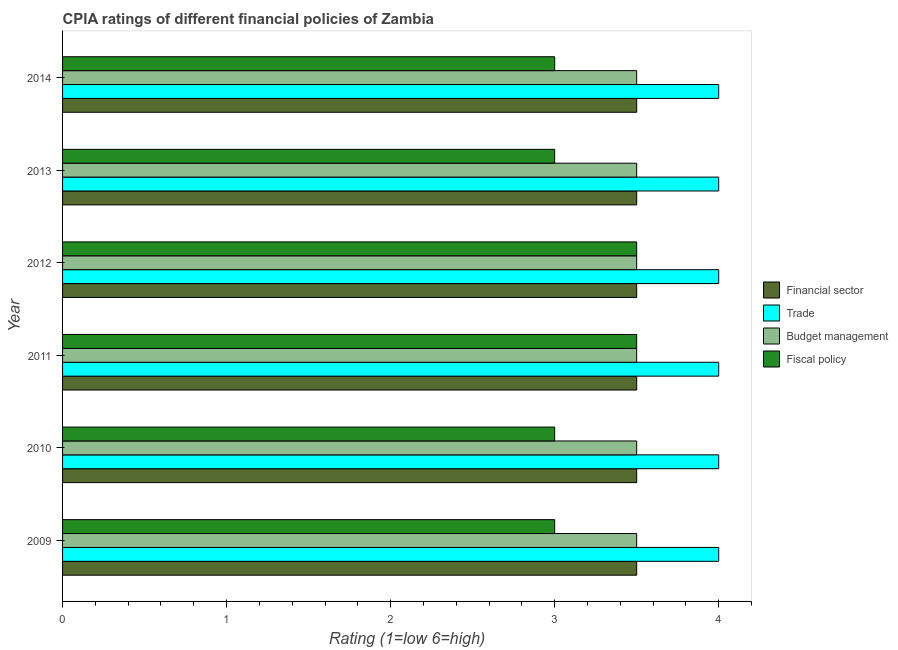How many groups of bars are there?
Offer a very short reply. 6. How many bars are there on the 3rd tick from the top?
Give a very brief answer. 4. How many bars are there on the 6th tick from the bottom?
Give a very brief answer. 4. What is the label of the 1st group of bars from the top?
Your response must be concise. 2014. In how many cases, is the number of bars for a given year not equal to the number of legend labels?
Your response must be concise. 0. Across all years, what is the maximum cpia rating of trade?
Provide a succinct answer. 4. Across all years, what is the minimum cpia rating of trade?
Provide a short and direct response. 4. In which year was the cpia rating of fiscal policy maximum?
Provide a short and direct response. 2011. What is the total cpia rating of financial sector in the graph?
Offer a very short reply. 21. What is the average cpia rating of fiscal policy per year?
Ensure brevity in your answer.  3.17. In the year 2013, what is the difference between the cpia rating of trade and cpia rating of fiscal policy?
Your answer should be very brief. 1. Is the cpia rating of budget management in 2010 less than that in 2013?
Provide a succinct answer. No. What does the 4th bar from the top in 2012 represents?
Offer a very short reply. Financial sector. What does the 3rd bar from the bottom in 2009 represents?
Ensure brevity in your answer.  Budget management. Are the values on the major ticks of X-axis written in scientific E-notation?
Make the answer very short. No. Does the graph contain grids?
Make the answer very short. No. Where does the legend appear in the graph?
Your answer should be very brief. Center right. How many legend labels are there?
Your answer should be compact. 4. What is the title of the graph?
Ensure brevity in your answer.  CPIA ratings of different financial policies of Zambia. What is the Rating (1=low 6=high) in Fiscal policy in 2009?
Keep it short and to the point. 3. What is the Rating (1=low 6=high) of Trade in 2010?
Give a very brief answer. 4. What is the Rating (1=low 6=high) of Trade in 2011?
Your answer should be compact. 4. What is the Rating (1=low 6=high) in Budget management in 2011?
Keep it short and to the point. 3.5. What is the Rating (1=low 6=high) of Financial sector in 2012?
Provide a succinct answer. 3.5. What is the Rating (1=low 6=high) of Budget management in 2012?
Offer a very short reply. 3.5. What is the Rating (1=low 6=high) of Financial sector in 2013?
Give a very brief answer. 3.5. What is the Rating (1=low 6=high) of Fiscal policy in 2013?
Your answer should be compact. 3. What is the Rating (1=low 6=high) of Trade in 2014?
Make the answer very short. 4. Across all years, what is the maximum Rating (1=low 6=high) of Financial sector?
Provide a short and direct response. 3.5. Across all years, what is the maximum Rating (1=low 6=high) of Trade?
Your response must be concise. 4. Across all years, what is the maximum Rating (1=low 6=high) of Budget management?
Keep it short and to the point. 3.5. Across all years, what is the minimum Rating (1=low 6=high) in Trade?
Provide a short and direct response. 4. Across all years, what is the minimum Rating (1=low 6=high) of Budget management?
Offer a terse response. 3.5. What is the total Rating (1=low 6=high) of Budget management in the graph?
Your answer should be compact. 21. What is the total Rating (1=low 6=high) of Fiscal policy in the graph?
Keep it short and to the point. 19. What is the difference between the Rating (1=low 6=high) of Fiscal policy in 2009 and that in 2011?
Give a very brief answer. -0.5. What is the difference between the Rating (1=low 6=high) in Trade in 2009 and that in 2012?
Your answer should be very brief. 0. What is the difference between the Rating (1=low 6=high) in Fiscal policy in 2009 and that in 2012?
Provide a succinct answer. -0.5. What is the difference between the Rating (1=low 6=high) of Budget management in 2009 and that in 2013?
Offer a terse response. 0. What is the difference between the Rating (1=low 6=high) in Fiscal policy in 2009 and that in 2013?
Provide a short and direct response. 0. What is the difference between the Rating (1=low 6=high) in Financial sector in 2009 and that in 2014?
Make the answer very short. 0. What is the difference between the Rating (1=low 6=high) of Trade in 2009 and that in 2014?
Give a very brief answer. 0. What is the difference between the Rating (1=low 6=high) of Fiscal policy in 2009 and that in 2014?
Provide a succinct answer. 0. What is the difference between the Rating (1=low 6=high) of Trade in 2010 and that in 2011?
Give a very brief answer. 0. What is the difference between the Rating (1=low 6=high) of Fiscal policy in 2010 and that in 2011?
Provide a succinct answer. -0.5. What is the difference between the Rating (1=low 6=high) of Trade in 2010 and that in 2012?
Keep it short and to the point. 0. What is the difference between the Rating (1=low 6=high) of Budget management in 2010 and that in 2012?
Offer a terse response. 0. What is the difference between the Rating (1=low 6=high) of Financial sector in 2010 and that in 2013?
Ensure brevity in your answer.  0. What is the difference between the Rating (1=low 6=high) in Trade in 2010 and that in 2013?
Offer a terse response. 0. What is the difference between the Rating (1=low 6=high) in Budget management in 2011 and that in 2012?
Provide a short and direct response. 0. What is the difference between the Rating (1=low 6=high) of Budget management in 2011 and that in 2013?
Offer a very short reply. 0. What is the difference between the Rating (1=low 6=high) of Fiscal policy in 2011 and that in 2013?
Make the answer very short. 0.5. What is the difference between the Rating (1=low 6=high) in Trade in 2011 and that in 2014?
Keep it short and to the point. 0. What is the difference between the Rating (1=low 6=high) of Fiscal policy in 2011 and that in 2014?
Ensure brevity in your answer.  0.5. What is the difference between the Rating (1=low 6=high) in Financial sector in 2012 and that in 2013?
Provide a short and direct response. 0. What is the difference between the Rating (1=low 6=high) of Trade in 2012 and that in 2013?
Your response must be concise. 0. What is the difference between the Rating (1=low 6=high) in Fiscal policy in 2012 and that in 2013?
Your response must be concise. 0.5. What is the difference between the Rating (1=low 6=high) in Budget management in 2012 and that in 2014?
Offer a very short reply. 0. What is the difference between the Rating (1=low 6=high) in Financial sector in 2013 and that in 2014?
Your answer should be very brief. 0. What is the difference between the Rating (1=low 6=high) of Trade in 2013 and that in 2014?
Your answer should be compact. 0. What is the difference between the Rating (1=low 6=high) of Fiscal policy in 2013 and that in 2014?
Your answer should be very brief. 0. What is the difference between the Rating (1=low 6=high) of Financial sector in 2009 and the Rating (1=low 6=high) of Trade in 2010?
Make the answer very short. -0.5. What is the difference between the Rating (1=low 6=high) in Financial sector in 2009 and the Rating (1=low 6=high) in Fiscal policy in 2010?
Provide a short and direct response. 0.5. What is the difference between the Rating (1=low 6=high) in Trade in 2009 and the Rating (1=low 6=high) in Budget management in 2010?
Give a very brief answer. 0.5. What is the difference between the Rating (1=low 6=high) in Trade in 2009 and the Rating (1=low 6=high) in Fiscal policy in 2010?
Provide a short and direct response. 1. What is the difference between the Rating (1=low 6=high) of Budget management in 2009 and the Rating (1=low 6=high) of Fiscal policy in 2010?
Make the answer very short. 0.5. What is the difference between the Rating (1=low 6=high) in Budget management in 2009 and the Rating (1=low 6=high) in Fiscal policy in 2011?
Your response must be concise. 0. What is the difference between the Rating (1=low 6=high) in Financial sector in 2009 and the Rating (1=low 6=high) in Fiscal policy in 2012?
Provide a short and direct response. 0. What is the difference between the Rating (1=low 6=high) of Trade in 2009 and the Rating (1=low 6=high) of Budget management in 2012?
Your response must be concise. 0.5. What is the difference between the Rating (1=low 6=high) of Trade in 2009 and the Rating (1=low 6=high) of Fiscal policy in 2012?
Offer a terse response. 0.5. What is the difference between the Rating (1=low 6=high) in Budget management in 2009 and the Rating (1=low 6=high) in Fiscal policy in 2012?
Offer a terse response. 0. What is the difference between the Rating (1=low 6=high) in Financial sector in 2009 and the Rating (1=low 6=high) in Trade in 2014?
Provide a succinct answer. -0.5. What is the difference between the Rating (1=low 6=high) in Financial sector in 2009 and the Rating (1=low 6=high) in Budget management in 2014?
Provide a succinct answer. 0. What is the difference between the Rating (1=low 6=high) in Financial sector in 2009 and the Rating (1=low 6=high) in Fiscal policy in 2014?
Your answer should be very brief. 0.5. What is the difference between the Rating (1=low 6=high) in Trade in 2009 and the Rating (1=low 6=high) in Fiscal policy in 2014?
Your answer should be very brief. 1. What is the difference between the Rating (1=low 6=high) of Financial sector in 2010 and the Rating (1=low 6=high) of Budget management in 2011?
Offer a very short reply. 0. What is the difference between the Rating (1=low 6=high) of Financial sector in 2010 and the Rating (1=low 6=high) of Fiscal policy in 2011?
Keep it short and to the point. 0. What is the difference between the Rating (1=low 6=high) of Trade in 2010 and the Rating (1=low 6=high) of Budget management in 2011?
Keep it short and to the point. 0.5. What is the difference between the Rating (1=low 6=high) of Budget management in 2010 and the Rating (1=low 6=high) of Fiscal policy in 2011?
Offer a terse response. 0. What is the difference between the Rating (1=low 6=high) in Financial sector in 2010 and the Rating (1=low 6=high) in Budget management in 2013?
Offer a terse response. 0. What is the difference between the Rating (1=low 6=high) in Financial sector in 2010 and the Rating (1=low 6=high) in Fiscal policy in 2013?
Provide a short and direct response. 0.5. What is the difference between the Rating (1=low 6=high) of Trade in 2010 and the Rating (1=low 6=high) of Budget management in 2013?
Your response must be concise. 0.5. What is the difference between the Rating (1=low 6=high) in Financial sector in 2010 and the Rating (1=low 6=high) in Trade in 2014?
Provide a short and direct response. -0.5. What is the difference between the Rating (1=low 6=high) of Financial sector in 2010 and the Rating (1=low 6=high) of Budget management in 2014?
Keep it short and to the point. 0. What is the difference between the Rating (1=low 6=high) in Financial sector in 2010 and the Rating (1=low 6=high) in Fiscal policy in 2014?
Provide a short and direct response. 0.5. What is the difference between the Rating (1=low 6=high) of Trade in 2010 and the Rating (1=low 6=high) of Fiscal policy in 2014?
Keep it short and to the point. 1. What is the difference between the Rating (1=low 6=high) of Financial sector in 2011 and the Rating (1=low 6=high) of Trade in 2012?
Make the answer very short. -0.5. What is the difference between the Rating (1=low 6=high) in Financial sector in 2011 and the Rating (1=low 6=high) in Budget management in 2013?
Your answer should be compact. 0. What is the difference between the Rating (1=low 6=high) in Trade in 2011 and the Rating (1=low 6=high) in Budget management in 2013?
Your answer should be very brief. 0.5. What is the difference between the Rating (1=low 6=high) in Financial sector in 2012 and the Rating (1=low 6=high) in Trade in 2013?
Your answer should be compact. -0.5. What is the difference between the Rating (1=low 6=high) in Financial sector in 2012 and the Rating (1=low 6=high) in Budget management in 2013?
Your answer should be compact. 0. What is the difference between the Rating (1=low 6=high) of Financial sector in 2012 and the Rating (1=low 6=high) of Fiscal policy in 2013?
Your response must be concise. 0.5. What is the difference between the Rating (1=low 6=high) of Trade in 2012 and the Rating (1=low 6=high) of Budget management in 2013?
Your response must be concise. 0.5. What is the difference between the Rating (1=low 6=high) of Trade in 2012 and the Rating (1=low 6=high) of Fiscal policy in 2013?
Offer a very short reply. 1. What is the difference between the Rating (1=low 6=high) of Budget management in 2012 and the Rating (1=low 6=high) of Fiscal policy in 2013?
Provide a short and direct response. 0.5. What is the difference between the Rating (1=low 6=high) in Financial sector in 2012 and the Rating (1=low 6=high) in Budget management in 2014?
Your response must be concise. 0. What is the difference between the Rating (1=low 6=high) in Trade in 2012 and the Rating (1=low 6=high) in Budget management in 2014?
Make the answer very short. 0.5. What is the difference between the Rating (1=low 6=high) of Budget management in 2012 and the Rating (1=low 6=high) of Fiscal policy in 2014?
Provide a short and direct response. 0.5. What is the difference between the Rating (1=low 6=high) in Financial sector in 2013 and the Rating (1=low 6=high) in Budget management in 2014?
Offer a very short reply. 0. What is the difference between the Rating (1=low 6=high) in Trade in 2013 and the Rating (1=low 6=high) in Budget management in 2014?
Your answer should be very brief. 0.5. What is the difference between the Rating (1=low 6=high) of Trade in 2013 and the Rating (1=low 6=high) of Fiscal policy in 2014?
Give a very brief answer. 1. What is the difference between the Rating (1=low 6=high) in Budget management in 2013 and the Rating (1=low 6=high) in Fiscal policy in 2014?
Provide a short and direct response. 0.5. What is the average Rating (1=low 6=high) of Financial sector per year?
Ensure brevity in your answer.  3.5. What is the average Rating (1=low 6=high) of Fiscal policy per year?
Ensure brevity in your answer.  3.17. In the year 2009, what is the difference between the Rating (1=low 6=high) in Financial sector and Rating (1=low 6=high) in Trade?
Your answer should be compact. -0.5. In the year 2009, what is the difference between the Rating (1=low 6=high) of Financial sector and Rating (1=low 6=high) of Budget management?
Give a very brief answer. 0. In the year 2009, what is the difference between the Rating (1=low 6=high) of Financial sector and Rating (1=low 6=high) of Fiscal policy?
Give a very brief answer. 0.5. In the year 2009, what is the difference between the Rating (1=low 6=high) in Trade and Rating (1=low 6=high) in Budget management?
Provide a succinct answer. 0.5. In the year 2009, what is the difference between the Rating (1=low 6=high) of Trade and Rating (1=low 6=high) of Fiscal policy?
Give a very brief answer. 1. In the year 2009, what is the difference between the Rating (1=low 6=high) of Budget management and Rating (1=low 6=high) of Fiscal policy?
Your answer should be compact. 0.5. In the year 2010, what is the difference between the Rating (1=low 6=high) of Financial sector and Rating (1=low 6=high) of Trade?
Your answer should be compact. -0.5. In the year 2010, what is the difference between the Rating (1=low 6=high) of Financial sector and Rating (1=low 6=high) of Fiscal policy?
Provide a short and direct response. 0.5. In the year 2010, what is the difference between the Rating (1=low 6=high) in Trade and Rating (1=low 6=high) in Budget management?
Make the answer very short. 0.5. In the year 2010, what is the difference between the Rating (1=low 6=high) in Trade and Rating (1=low 6=high) in Fiscal policy?
Keep it short and to the point. 1. In the year 2011, what is the difference between the Rating (1=low 6=high) in Financial sector and Rating (1=low 6=high) in Budget management?
Make the answer very short. 0. In the year 2011, what is the difference between the Rating (1=low 6=high) of Financial sector and Rating (1=low 6=high) of Fiscal policy?
Provide a succinct answer. 0. In the year 2012, what is the difference between the Rating (1=low 6=high) of Financial sector and Rating (1=low 6=high) of Trade?
Your answer should be compact. -0.5. In the year 2012, what is the difference between the Rating (1=low 6=high) of Financial sector and Rating (1=low 6=high) of Budget management?
Your answer should be compact. 0. In the year 2012, what is the difference between the Rating (1=low 6=high) of Trade and Rating (1=low 6=high) of Fiscal policy?
Your response must be concise. 0.5. In the year 2013, what is the difference between the Rating (1=low 6=high) of Trade and Rating (1=low 6=high) of Fiscal policy?
Offer a terse response. 1. In the year 2014, what is the difference between the Rating (1=low 6=high) of Financial sector and Rating (1=low 6=high) of Budget management?
Your answer should be compact. 0. In the year 2014, what is the difference between the Rating (1=low 6=high) in Financial sector and Rating (1=low 6=high) in Fiscal policy?
Ensure brevity in your answer.  0.5. In the year 2014, what is the difference between the Rating (1=low 6=high) in Trade and Rating (1=low 6=high) in Budget management?
Your answer should be compact. 0.5. What is the ratio of the Rating (1=low 6=high) in Financial sector in 2009 to that in 2010?
Give a very brief answer. 1. What is the ratio of the Rating (1=low 6=high) of Trade in 2009 to that in 2010?
Ensure brevity in your answer.  1. What is the ratio of the Rating (1=low 6=high) of Budget management in 2009 to that in 2010?
Your response must be concise. 1. What is the ratio of the Rating (1=low 6=high) in Fiscal policy in 2009 to that in 2010?
Your answer should be compact. 1. What is the ratio of the Rating (1=low 6=high) in Financial sector in 2009 to that in 2012?
Ensure brevity in your answer.  1. What is the ratio of the Rating (1=low 6=high) of Trade in 2009 to that in 2012?
Offer a terse response. 1. What is the ratio of the Rating (1=low 6=high) in Budget management in 2009 to that in 2012?
Your answer should be compact. 1. What is the ratio of the Rating (1=low 6=high) in Fiscal policy in 2009 to that in 2012?
Provide a succinct answer. 0.86. What is the ratio of the Rating (1=low 6=high) of Trade in 2009 to that in 2013?
Keep it short and to the point. 1. What is the ratio of the Rating (1=low 6=high) of Fiscal policy in 2009 to that in 2013?
Ensure brevity in your answer.  1. What is the ratio of the Rating (1=low 6=high) in Financial sector in 2009 to that in 2014?
Make the answer very short. 1. What is the ratio of the Rating (1=low 6=high) of Fiscal policy in 2009 to that in 2014?
Provide a succinct answer. 1. What is the ratio of the Rating (1=low 6=high) of Financial sector in 2010 to that in 2012?
Your answer should be very brief. 1. What is the ratio of the Rating (1=low 6=high) in Trade in 2010 to that in 2012?
Provide a short and direct response. 1. What is the ratio of the Rating (1=low 6=high) in Financial sector in 2010 to that in 2013?
Your answer should be compact. 1. What is the ratio of the Rating (1=low 6=high) in Trade in 2010 to that in 2013?
Your answer should be compact. 1. What is the ratio of the Rating (1=low 6=high) of Budget management in 2010 to that in 2013?
Offer a very short reply. 1. What is the ratio of the Rating (1=low 6=high) of Fiscal policy in 2010 to that in 2013?
Your answer should be compact. 1. What is the ratio of the Rating (1=low 6=high) of Trade in 2010 to that in 2014?
Give a very brief answer. 1. What is the ratio of the Rating (1=low 6=high) in Budget management in 2010 to that in 2014?
Give a very brief answer. 1. What is the ratio of the Rating (1=low 6=high) of Trade in 2011 to that in 2012?
Keep it short and to the point. 1. What is the ratio of the Rating (1=low 6=high) in Budget management in 2011 to that in 2012?
Your response must be concise. 1. What is the ratio of the Rating (1=low 6=high) of Fiscal policy in 2011 to that in 2012?
Keep it short and to the point. 1. What is the ratio of the Rating (1=low 6=high) of Financial sector in 2011 to that in 2013?
Make the answer very short. 1. What is the ratio of the Rating (1=low 6=high) of Budget management in 2011 to that in 2013?
Provide a short and direct response. 1. What is the ratio of the Rating (1=low 6=high) of Fiscal policy in 2011 to that in 2013?
Make the answer very short. 1.17. What is the ratio of the Rating (1=low 6=high) of Fiscal policy in 2011 to that in 2014?
Your response must be concise. 1.17. What is the ratio of the Rating (1=low 6=high) of Budget management in 2012 to that in 2013?
Your answer should be compact. 1. What is the ratio of the Rating (1=low 6=high) in Fiscal policy in 2012 to that in 2013?
Offer a terse response. 1.17. What is the ratio of the Rating (1=low 6=high) of Budget management in 2012 to that in 2014?
Your answer should be very brief. 1. What is the ratio of the Rating (1=low 6=high) in Fiscal policy in 2012 to that in 2014?
Your answer should be compact. 1.17. What is the ratio of the Rating (1=low 6=high) in Financial sector in 2013 to that in 2014?
Your response must be concise. 1. What is the ratio of the Rating (1=low 6=high) in Trade in 2013 to that in 2014?
Offer a terse response. 1. What is the ratio of the Rating (1=low 6=high) in Budget management in 2013 to that in 2014?
Offer a very short reply. 1. What is the difference between the highest and the second highest Rating (1=low 6=high) of Financial sector?
Provide a short and direct response. 0. What is the difference between the highest and the second highest Rating (1=low 6=high) in Trade?
Provide a succinct answer. 0. What is the difference between the highest and the second highest Rating (1=low 6=high) in Budget management?
Keep it short and to the point. 0. What is the difference between the highest and the second highest Rating (1=low 6=high) in Fiscal policy?
Provide a succinct answer. 0. What is the difference between the highest and the lowest Rating (1=low 6=high) in Trade?
Make the answer very short. 0. 